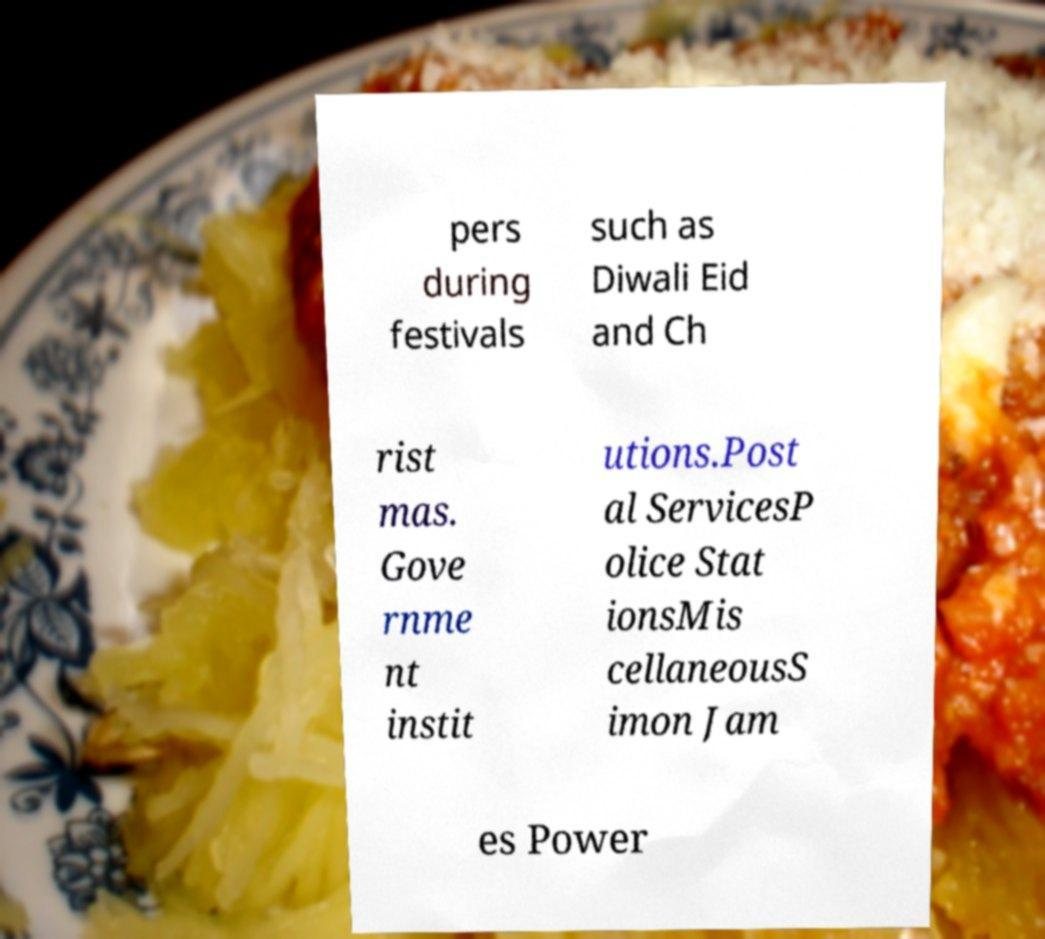Can you read and provide the text displayed in the image?This photo seems to have some interesting text. Can you extract and type it out for me? pers during festivals such as Diwali Eid and Ch rist mas. Gove rnme nt instit utions.Post al ServicesP olice Stat ionsMis cellaneousS imon Jam es Power 